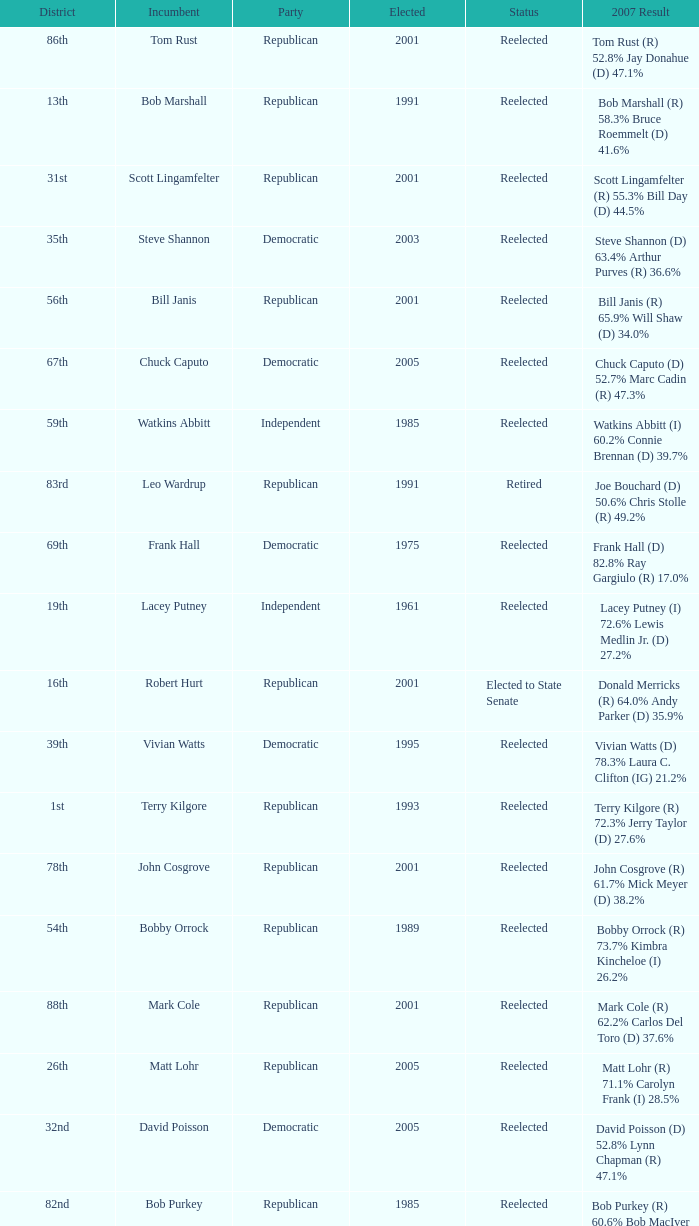What district is incument terry kilgore from? 1st. 